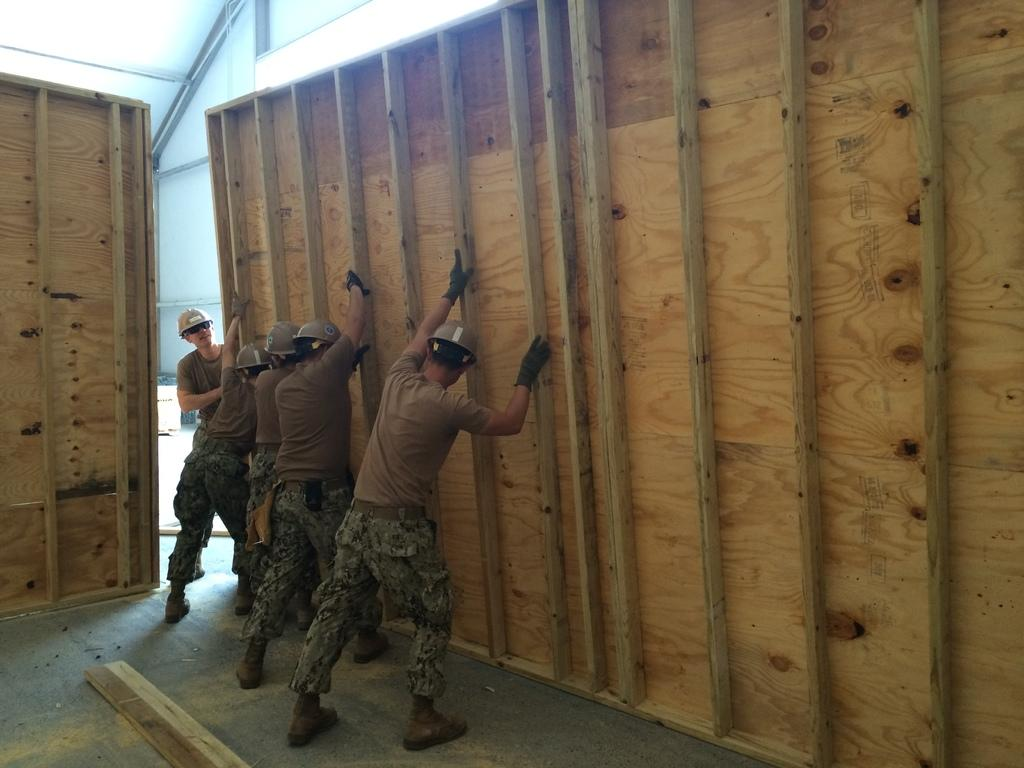How many people are in the image? There are many persons standing in the image. What are the persons holding in the image? The persons are holding a wooden board. Where is the wooden board located in the image? The wooden board is on the left side of the image. What can be seen in the background of the image? There is a wall in the background of the image. What type of drum is being played by the beginner in the image? There is no drum or beginner present in the image. 